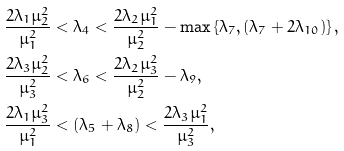<formula> <loc_0><loc_0><loc_500><loc_500>\frac { 2 \lambda _ { 1 } \mu _ { 2 } ^ { 2 } } { \mu _ { 1 } ^ { 2 } } & < \lambda _ { 4 } < \frac { 2 \lambda _ { 2 } \mu _ { 1 } ^ { 2 } } { \mu _ { 2 } ^ { 2 } } - \max \left \{ \lambda _ { 7 } , ( \lambda _ { 7 } + 2 \lambda _ { 1 0 } ) \right \} , \\ \frac { 2 \lambda _ { 3 } \mu _ { 2 } ^ { 2 } } { \mu _ { 3 } ^ { 2 } } & < \lambda _ { 6 } < \frac { 2 \lambda _ { 2 } \mu _ { 3 } ^ { 2 } } { \mu _ { 2 } ^ { 2 } } - \lambda _ { 9 } , \\ \frac { 2 \lambda _ { 1 } \mu _ { 3 } ^ { 2 } } { \mu _ { 1 } ^ { 2 } } & < ( \lambda _ { 5 } + \lambda _ { 8 } ) < \frac { 2 \lambda _ { 3 } \mu _ { 1 } ^ { 2 } } { \mu _ { 3 } ^ { 2 } } ,</formula> 